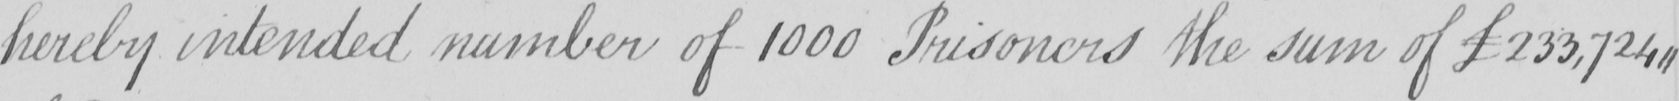Please provide the text content of this handwritten line. hereby intended number of 1000 Prisoners the sum of £233,724, , 